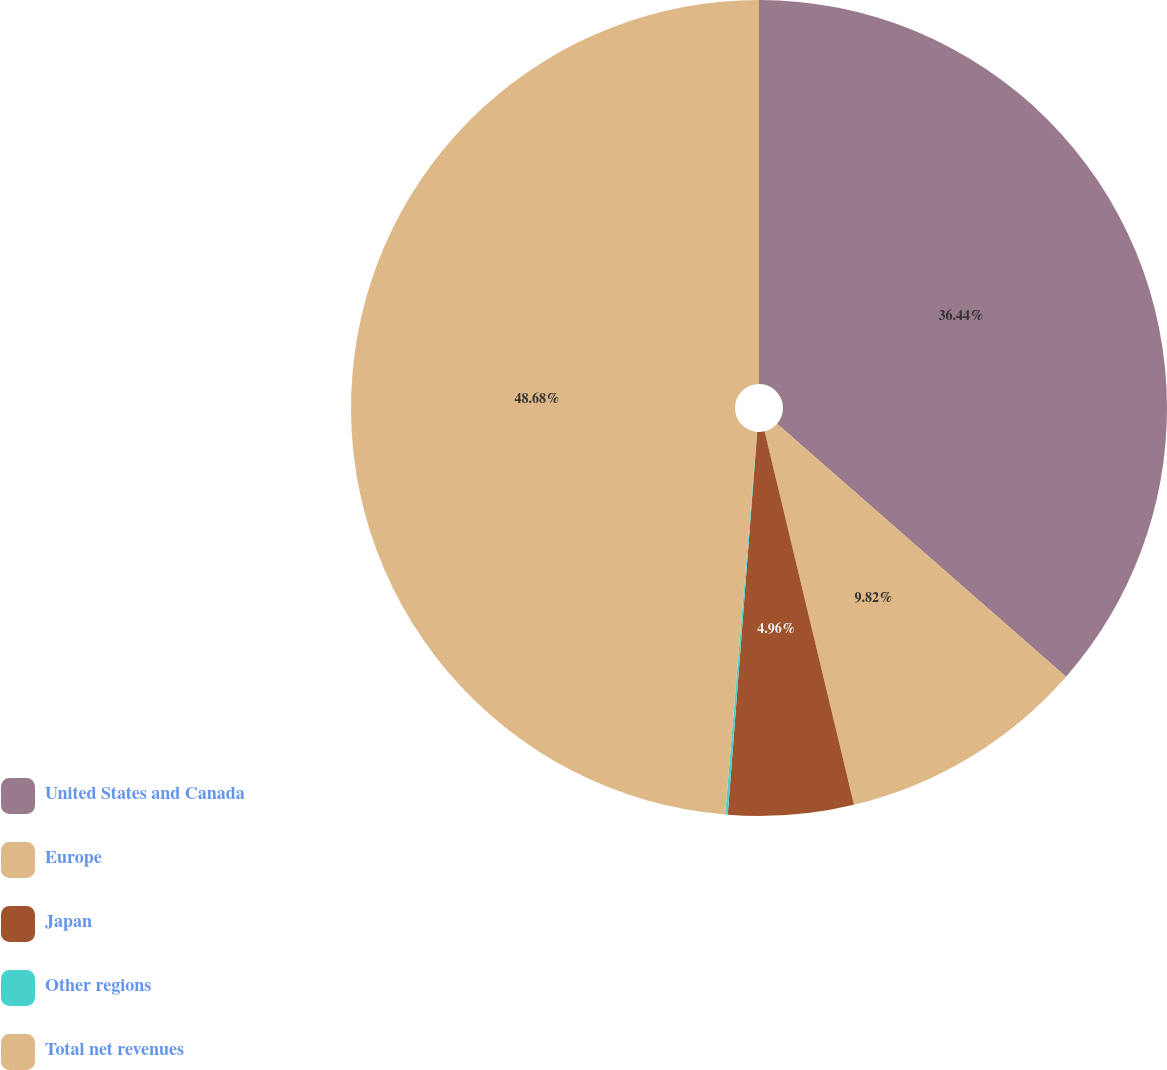Convert chart. <chart><loc_0><loc_0><loc_500><loc_500><pie_chart><fcel>United States and Canada<fcel>Europe<fcel>Japan<fcel>Other regions<fcel>Total net revenues<nl><fcel>36.44%<fcel>9.82%<fcel>4.96%<fcel>0.1%<fcel>48.68%<nl></chart> 